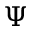Convert formula to latex. <formula><loc_0><loc_0><loc_500><loc_500>\Psi</formula> 